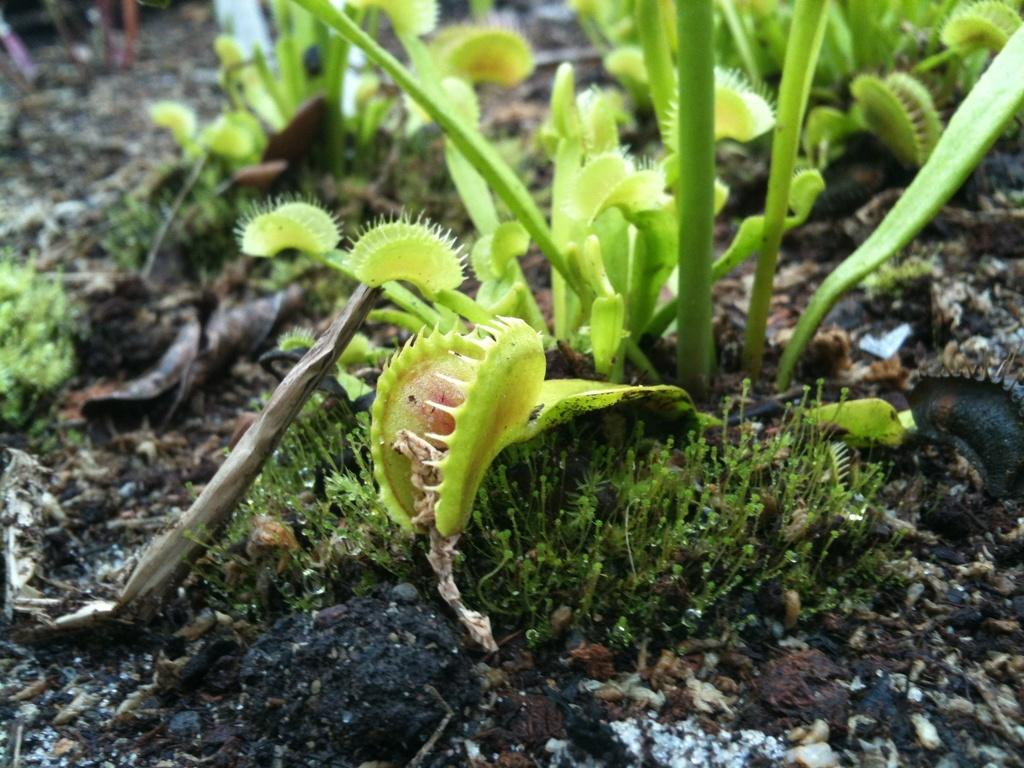What type of living organisms can be seen in the image? Plants can be seen in the image. What type of cough medicine is visible in the image? There is no cough medicine present in the image; it only features plants. 